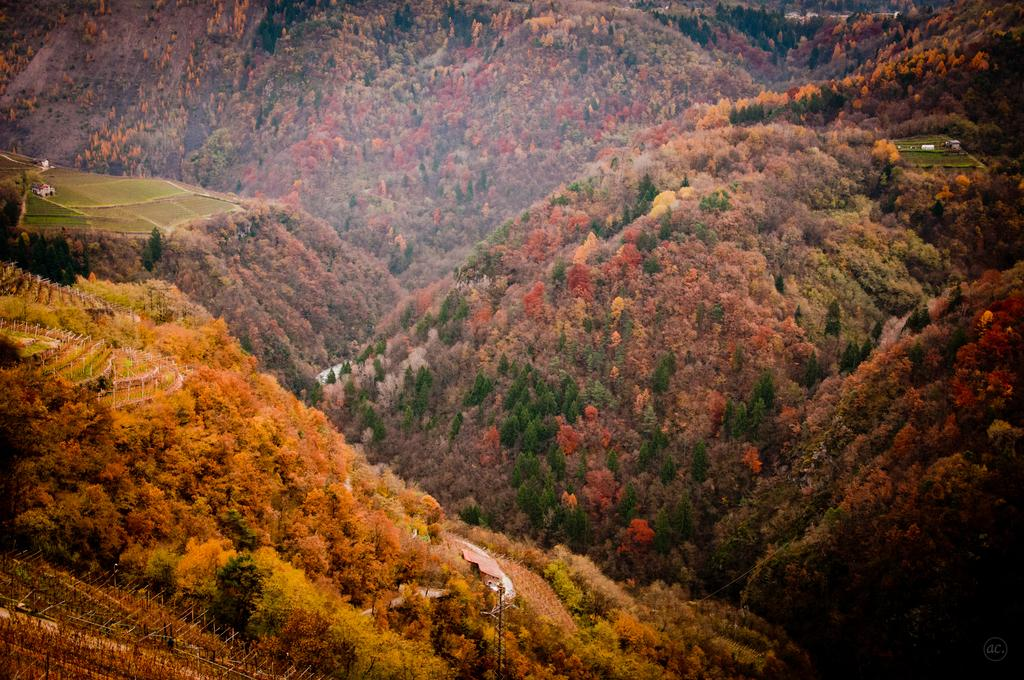What type of natural formation can be seen in the image? There are mountains in the image. What type of vegetation is present in the image? There are trees in the image. What type of engine can be seen in the image? There is no engine present in the image; it features mountains and trees. How many pins are visible in the image? There are no pins visible in the image. 